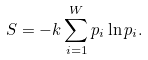<formula> <loc_0><loc_0><loc_500><loc_500>S = - k \sum _ { i = 1 } ^ { W } p _ { i } \ln p _ { i } .</formula> 